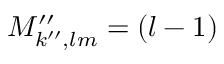<formula> <loc_0><loc_0><loc_500><loc_500>M _ { k ^ { \prime \prime } , l m } ^ { \prime \prime } = ( l - 1 )</formula> 